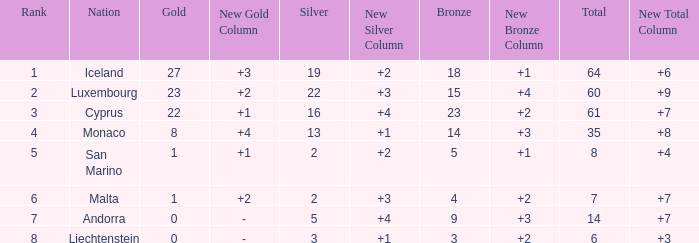Where does Iceland rank with under 19 silvers? None. 